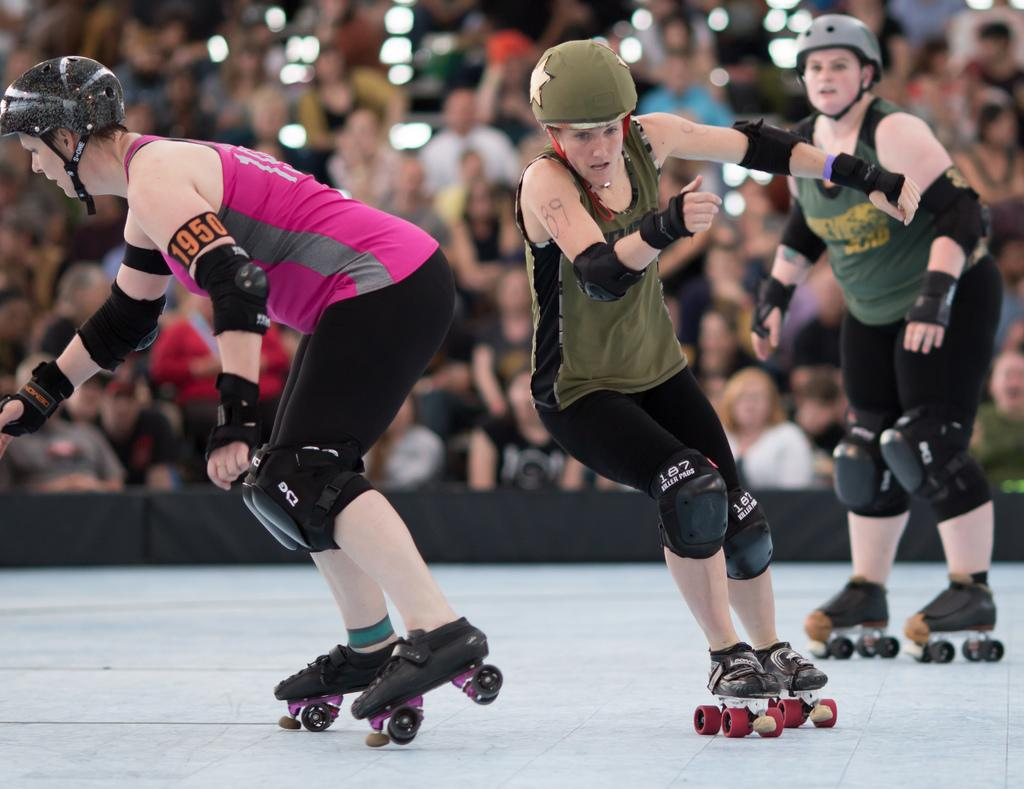What are the persons in the image wearing on their feet? The persons in the image are wearing skate wheels. What can be seen in the background of the image? There are other persons and objects in the background of the image. What is visible at the bottom of the image? The floor is visible at the bottom of the image. Where are the rabbits hiding in the image? There are no rabbits present in the image. What type of tin is being used to store the skate wheels in the image? There is no tin present in the image; the skate wheels are being worn by the persons. 